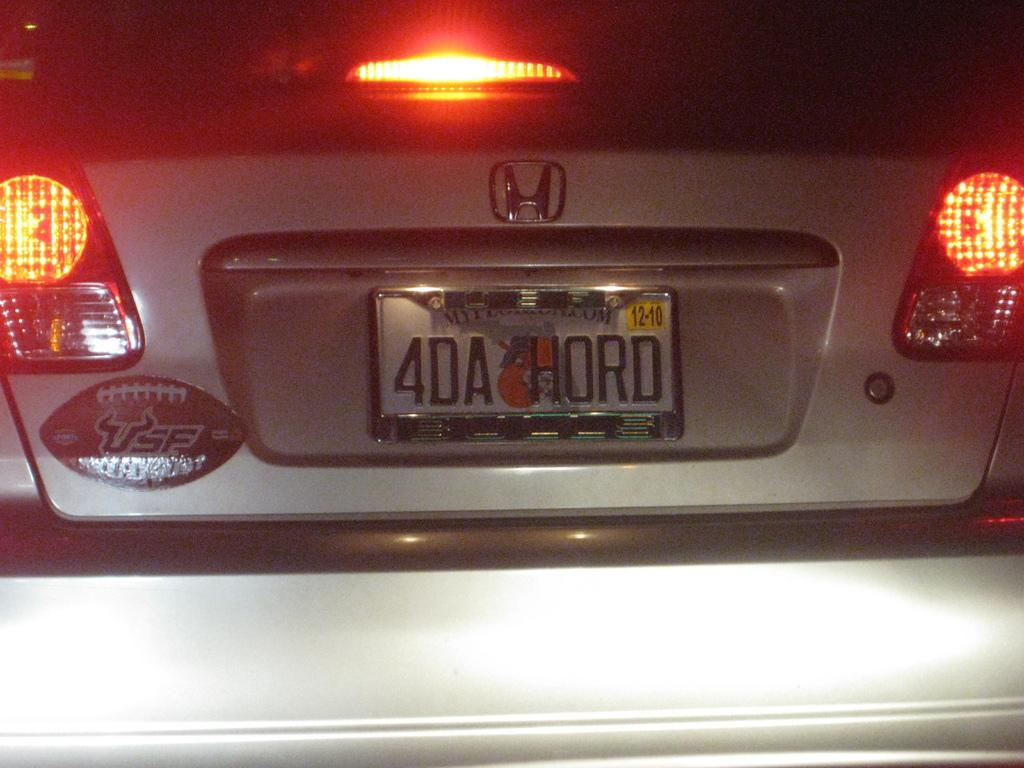<image>
Give a short and clear explanation of the subsequent image. The back of a car has a USF bumper sticker. 